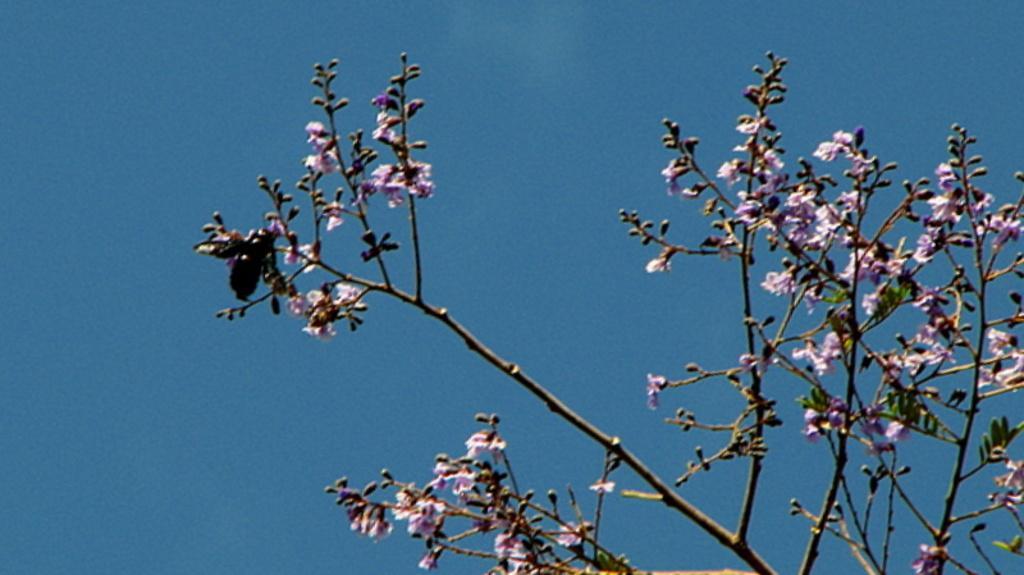In one or two sentences, can you explain what this image depicts? Here we can see branches and flowers. There is an insect. In the background there is sky. 